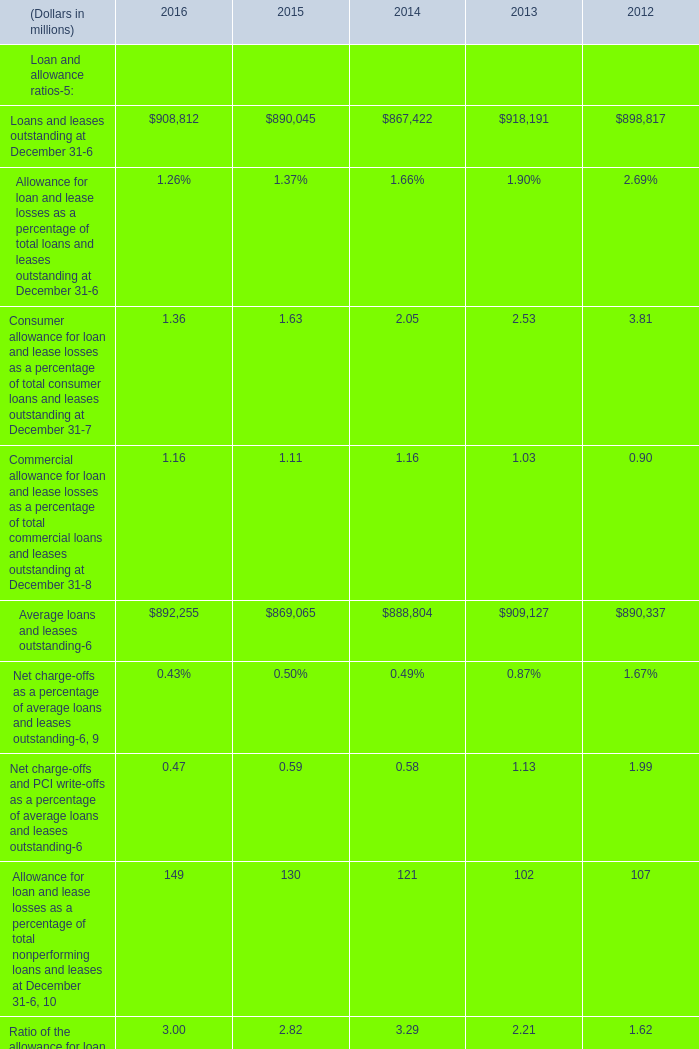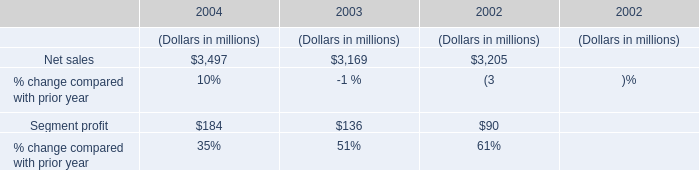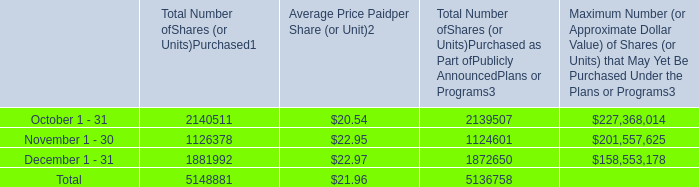what is the total cash used for the repurchase of shares during october , ( in millions ) ? 
Computations: ((2140511 * 20.54) / 1000000)
Answer: 43.9661. 